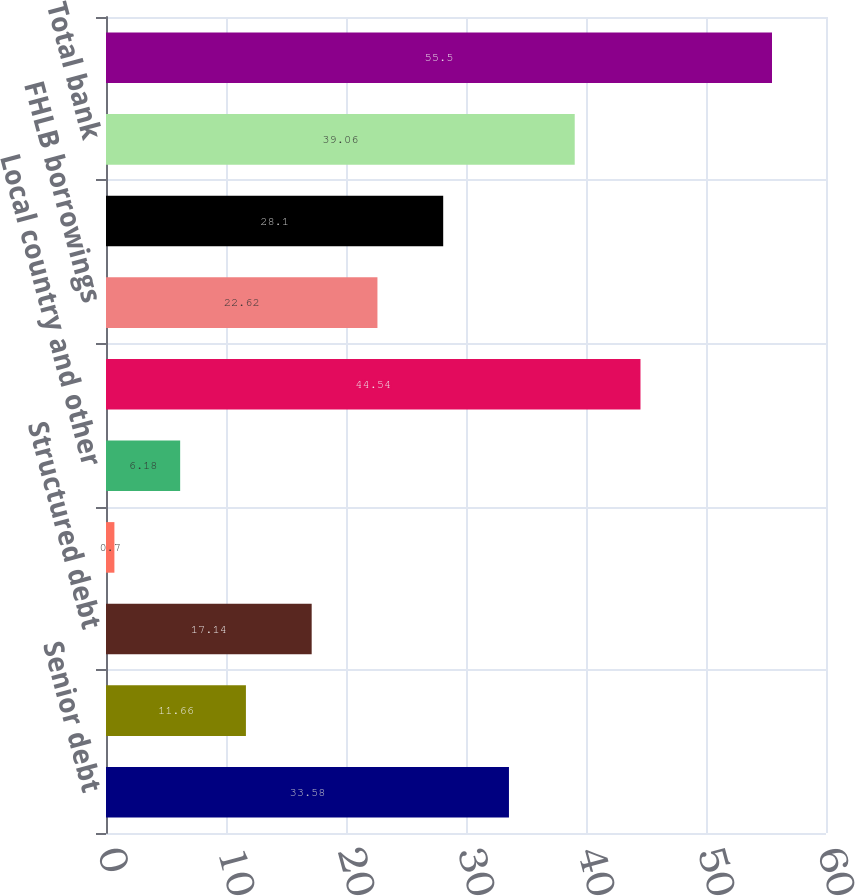Convert chart. <chart><loc_0><loc_0><loc_500><loc_500><bar_chart><fcel>Senior debt<fcel>Subordinated debt<fcel>Structured debt<fcel>Non-structured debt<fcel>Local country and other<fcel>Total parent and other<fcel>FHLB borrowings<fcel>Securitizations<fcel>Total bank<fcel>Total<nl><fcel>33.58<fcel>11.66<fcel>17.14<fcel>0.7<fcel>6.18<fcel>44.54<fcel>22.62<fcel>28.1<fcel>39.06<fcel>55.5<nl></chart> 